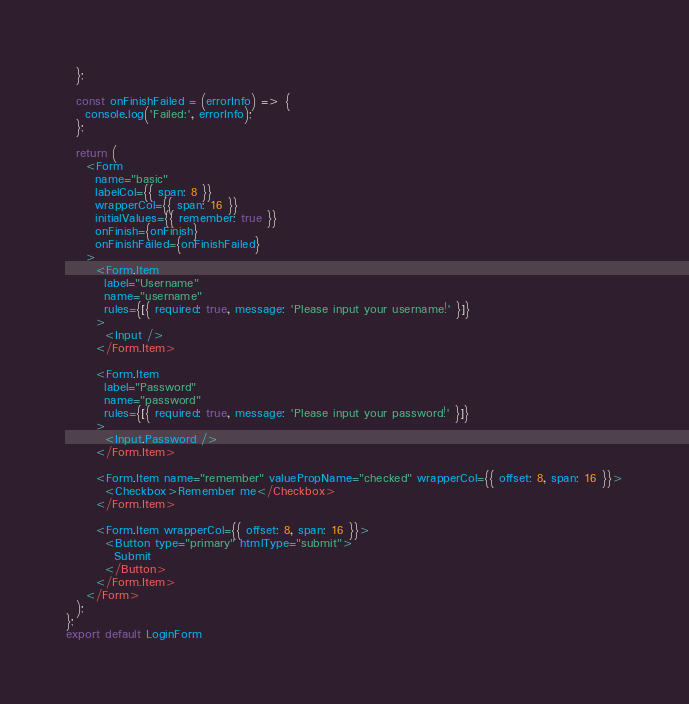Convert code to text. <code><loc_0><loc_0><loc_500><loc_500><_JavaScript_>  };

  const onFinishFailed = (errorInfo) => {
    console.log('Failed:', errorInfo);
  };

  return (
    <Form
      name="basic"
      labelCol={{ span: 8 }}
      wrapperCol={{ span: 16 }}
      initialValues={{ remember: true }}
      onFinish={onFinish}
      onFinishFailed={onFinishFailed}
    >
      <Form.Item
        label="Username"
        name="username"
        rules={[{ required: true, message: 'Please input your username!' }]}
      >
        <Input />
      </Form.Item>

      <Form.Item
        label="Password"
        name="password"
        rules={[{ required: true, message: 'Please input your password!' }]}
      >
        <Input.Password />
      </Form.Item>

      <Form.Item name="remember" valuePropName="checked" wrapperCol={{ offset: 8, span: 16 }}>
        <Checkbox>Remember me</Checkbox>
      </Form.Item>

      <Form.Item wrapperCol={{ offset: 8, span: 16 }}>
        <Button type="primary" htmlType="submit">
          Submit
        </Button>
      </Form.Item>
    </Form>
  );
};
export default LoginForm
</code> 